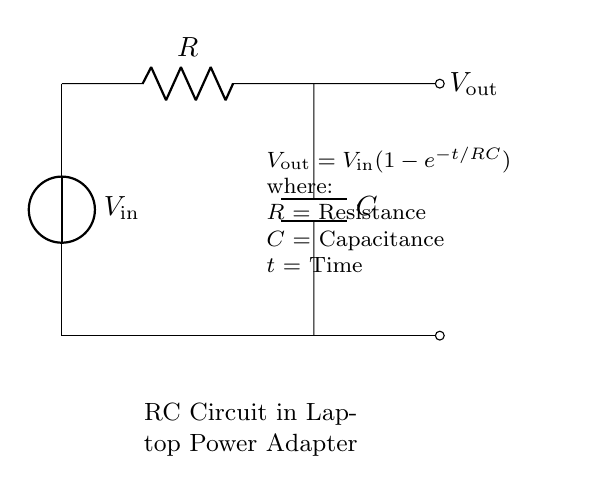What are the components in this circuit? The circuit contains a voltage source (V), a resistor (R), and a capacitor (C). These components are represented visually and labeled in the diagram.
Answer: voltage source, resistor, capacitor What is the output voltage represented in the circuit? The output voltage is indicated as V_out, which is the voltage across the capacitor in the circuit. It is derived from the input voltage (V_in) and the time constant of the resistor-capacitor combination.
Answer: V_out What is the time constant of this RC circuit? The time constant (τ) of an RC circuit is given by τ = R * C, where R is the resistance and C is the capacitance. This constant indicates how quickly the capacitor charges to approximately 63.2% of V_in.
Answer: R * C How does the output voltage behave over time? The output voltage rises according to the equation V_out = V_in(1-e^{-t/RC}), where it approaches V_in as time increases. This means that initially the output voltage increases rapidly and then gradually approaches the input voltage value.
Answer: approaches V_in What happens when resistance is increased in this circuit? Increasing the resistance increases the time constant (τ = R * C), which results in a slower charge time for the capacitor and thus a slower rise in output voltage. The output voltage will still reach the same final value but will take longer to do so.
Answer: slower charging What does the equation V_out = V_in(1-e^{-t/RC}) represent? This equation describes the relationship between input voltage, output voltage, time, resistance, and capacitance in an RC charging circuit. It shows how the output voltage approaches the input voltage over time with respect to the time constant.
Answer: charging behavior What type of circuit is this? This is a resistor-capacitor (RC) circuit, commonly used for voltage regulation in power adapters. It utilizes the charging and discharging characteristics of a capacitor to smooth out voltage fluctuations.
Answer: resistor-capacitor circuit 